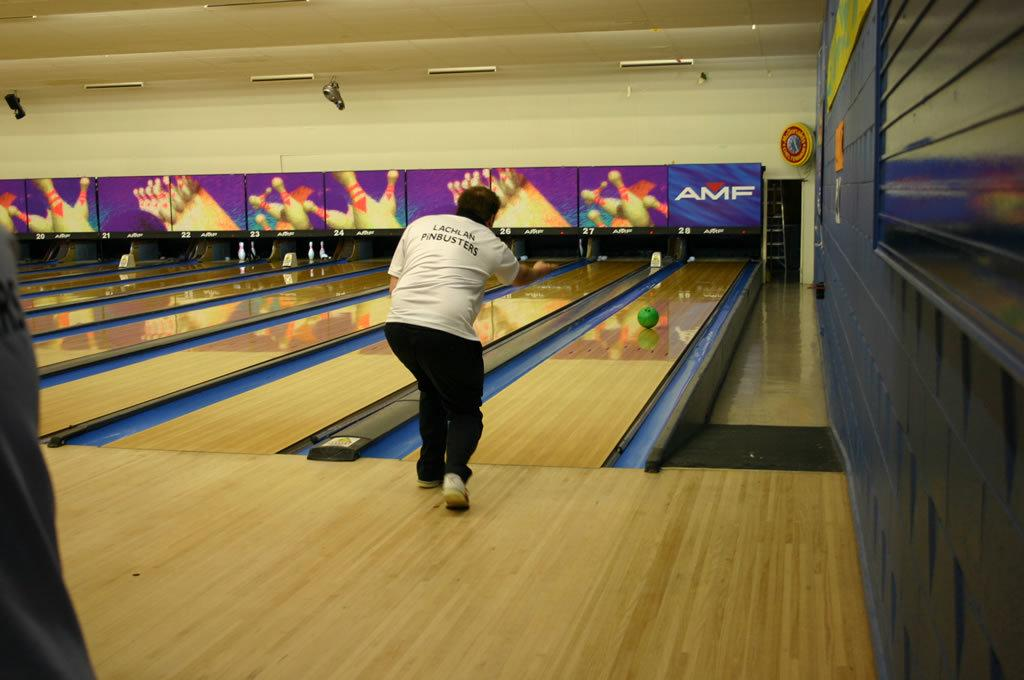What activity is taking place in the image? The image depicts a game of Ten-pin-bowling. Can you describe the person in the image? There is a person in the image. What is the person doing in the image? The person is throwing a ball. What type of shoe is the person wearing while holding a pencil in the image? There is no shoe or pencil present in the image; the person is throwing a ball during a game of Ten-pin-bowling. 